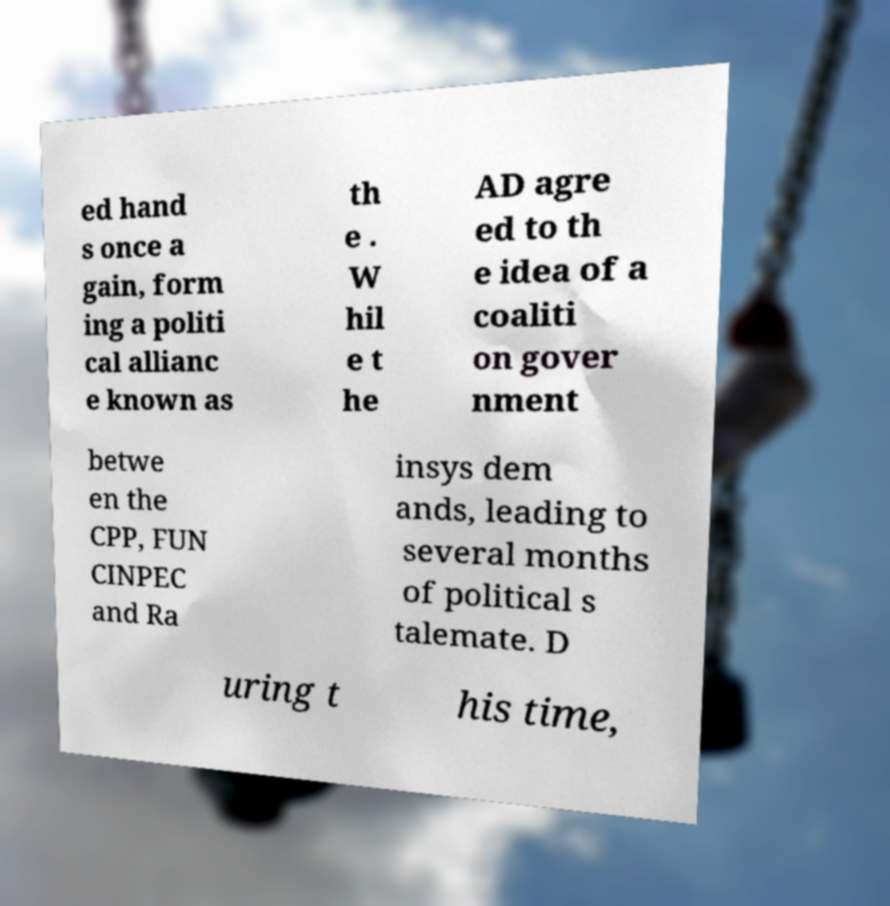Can you read and provide the text displayed in the image?This photo seems to have some interesting text. Can you extract and type it out for me? ed hand s once a gain, form ing a politi cal allianc e known as th e . W hil e t he AD agre ed to th e idea of a coaliti on gover nment betwe en the CPP, FUN CINPEC and Ra insys dem ands, leading to several months of political s talemate. D uring t his time, 